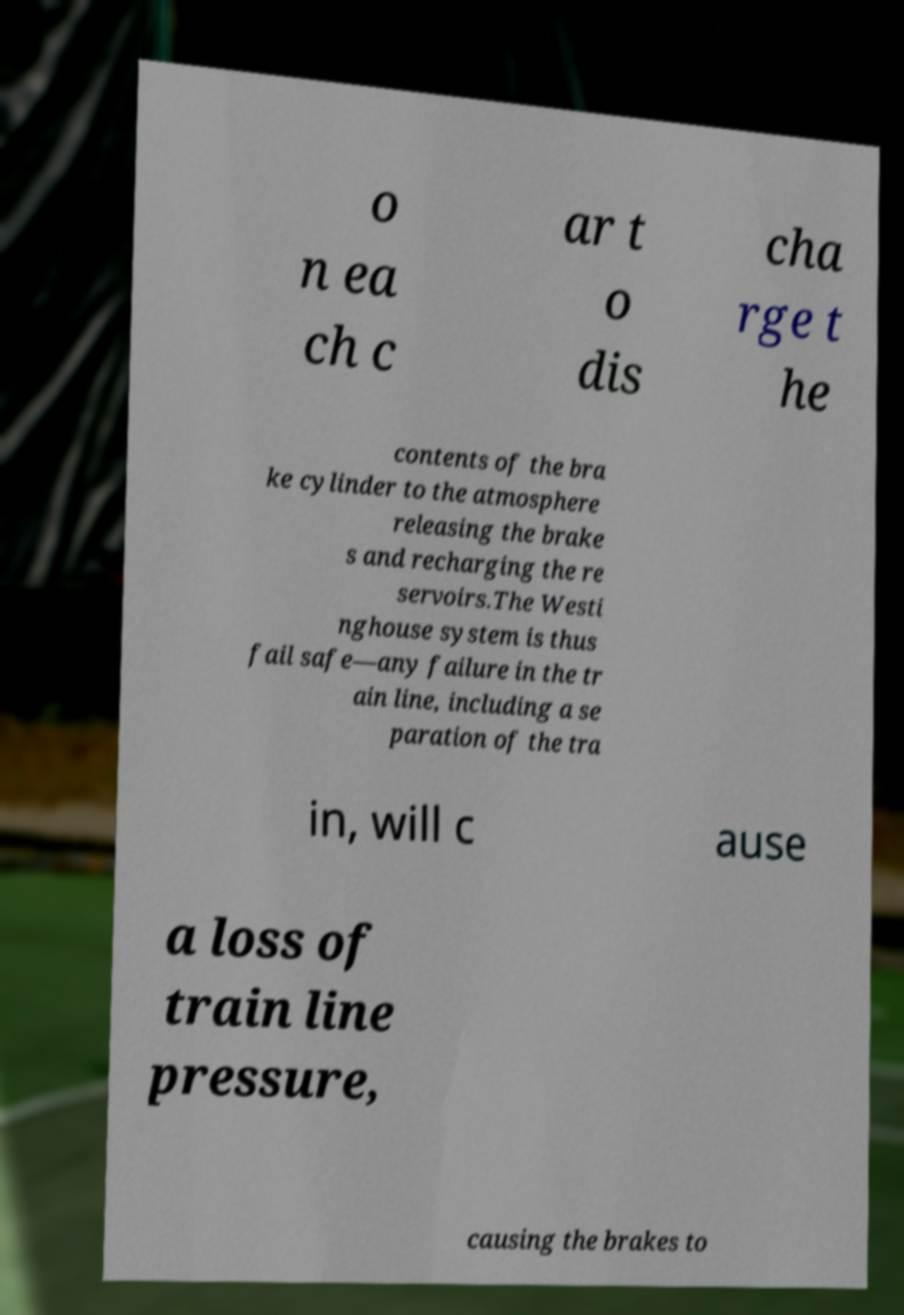Could you extract and type out the text from this image? o n ea ch c ar t o dis cha rge t he contents of the bra ke cylinder to the atmosphere releasing the brake s and recharging the re servoirs.The Westi nghouse system is thus fail safe—any failure in the tr ain line, including a se paration of the tra in, will c ause a loss of train line pressure, causing the brakes to 